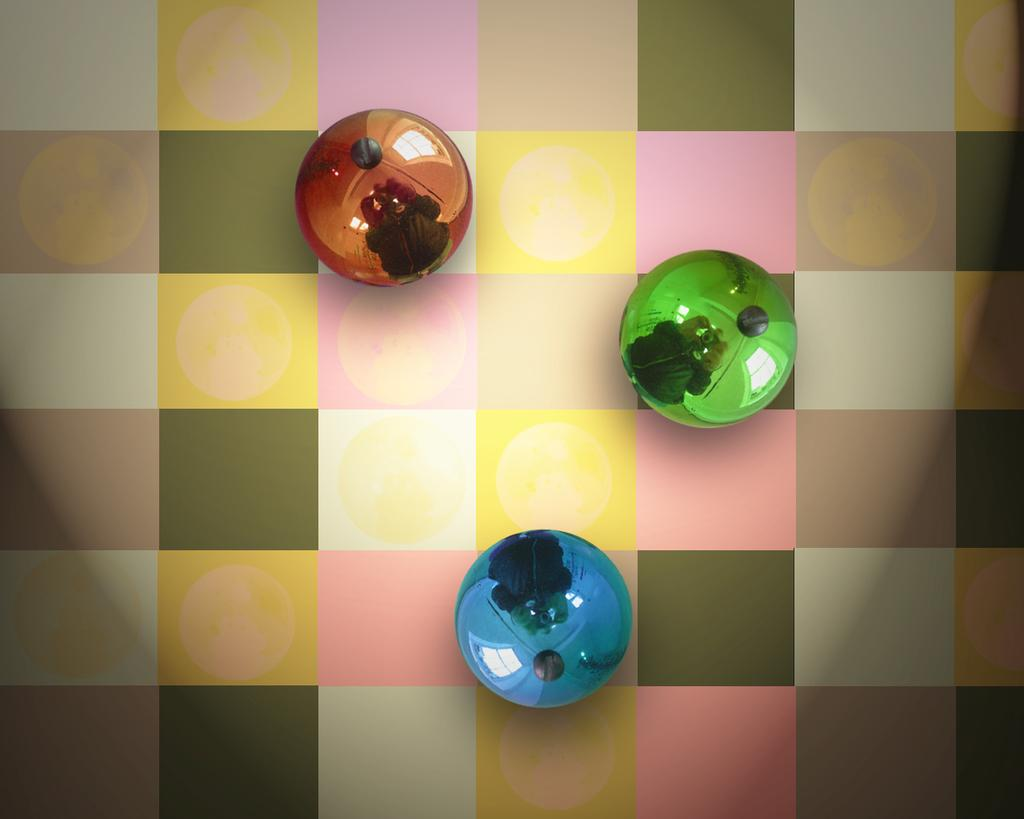How many balls are present in the image? There are three balls in the image. Where are the balls located in the image? The balls are on a board. What type of oatmeal is being served in the carriage in the image? There is no carriage or oatmeal present in the image; it only features three balls on a board. 